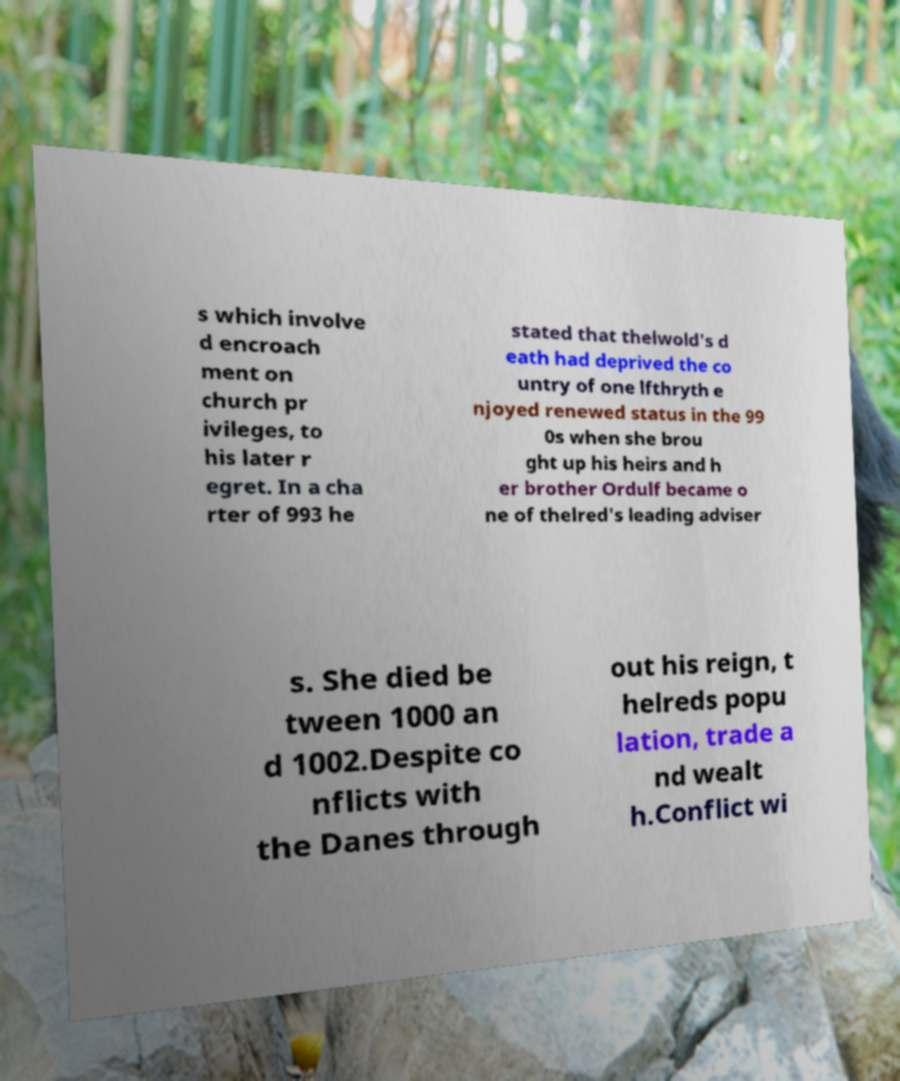Please read and relay the text visible in this image. What does it say? s which involve d encroach ment on church pr ivileges, to his later r egret. In a cha rter of 993 he stated that thelwold's d eath had deprived the co untry of one lfthryth e njoyed renewed status in the 99 0s when she brou ght up his heirs and h er brother Ordulf became o ne of thelred's leading adviser s. She died be tween 1000 an d 1002.Despite co nflicts with the Danes through out his reign, t helreds popu lation, trade a nd wealt h.Conflict wi 